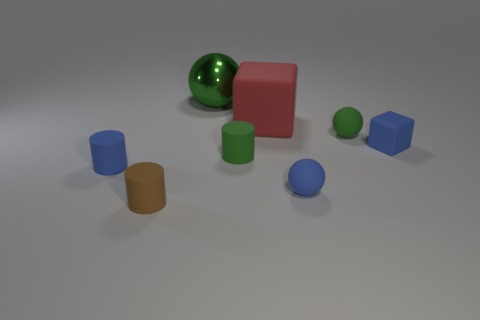Subtract all matte spheres. How many spheres are left? 1 Subtract 3 spheres. How many spheres are left? 0 Add 1 green matte balls. How many objects exist? 9 Subtract all green spheres. How many spheres are left? 1 Subtract all balls. How many objects are left? 5 Subtract 0 purple balls. How many objects are left? 8 Subtract all red cylinders. Subtract all purple blocks. How many cylinders are left? 3 Subtract all red cubes. How many blue balls are left? 1 Subtract all large green objects. Subtract all small blue cylinders. How many objects are left? 6 Add 2 small brown matte things. How many small brown matte things are left? 3 